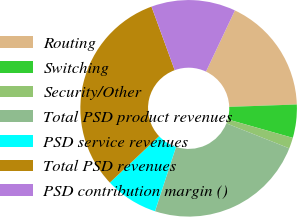Convert chart to OTSL. <chart><loc_0><loc_0><loc_500><loc_500><pie_chart><fcel>Routing<fcel>Switching<fcel>Security/Other<fcel>Total PSD product revenues<fcel>PSD service revenues<fcel>Total PSD revenues<fcel>PSD contribution margin ()<nl><fcel>17.41%<fcel>4.96%<fcel>1.63%<fcel>24.0%<fcel>7.94%<fcel>31.46%<fcel>12.6%<nl></chart> 